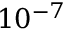<formula> <loc_0><loc_0><loc_500><loc_500>1 0 ^ { - 7 }</formula> 